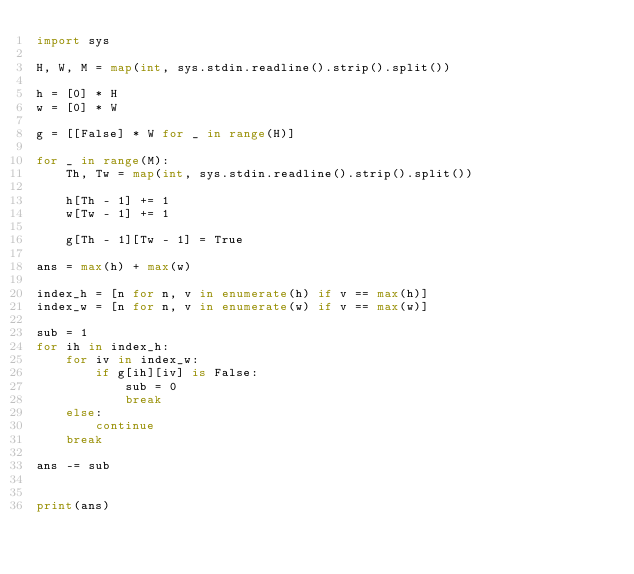Convert code to text. <code><loc_0><loc_0><loc_500><loc_500><_Python_>import sys

H, W, M = map(int, sys.stdin.readline().strip().split())

h = [0] * H
w = [0] * W

g = [[False] * W for _ in range(H)]

for _ in range(M):
    Th, Tw = map(int, sys.stdin.readline().strip().split())

    h[Th - 1] += 1
    w[Tw - 1] += 1

    g[Th - 1][Tw - 1] = True

ans = max(h) + max(w)

index_h = [n for n, v in enumerate(h) if v == max(h)]
index_w = [n for n, v in enumerate(w) if v == max(w)]

sub = 1
for ih in index_h:
    for iv in index_w:
        if g[ih][iv] is False:
            sub = 0
            break
    else:
        continue
    break

ans -= sub


print(ans)

</code> 